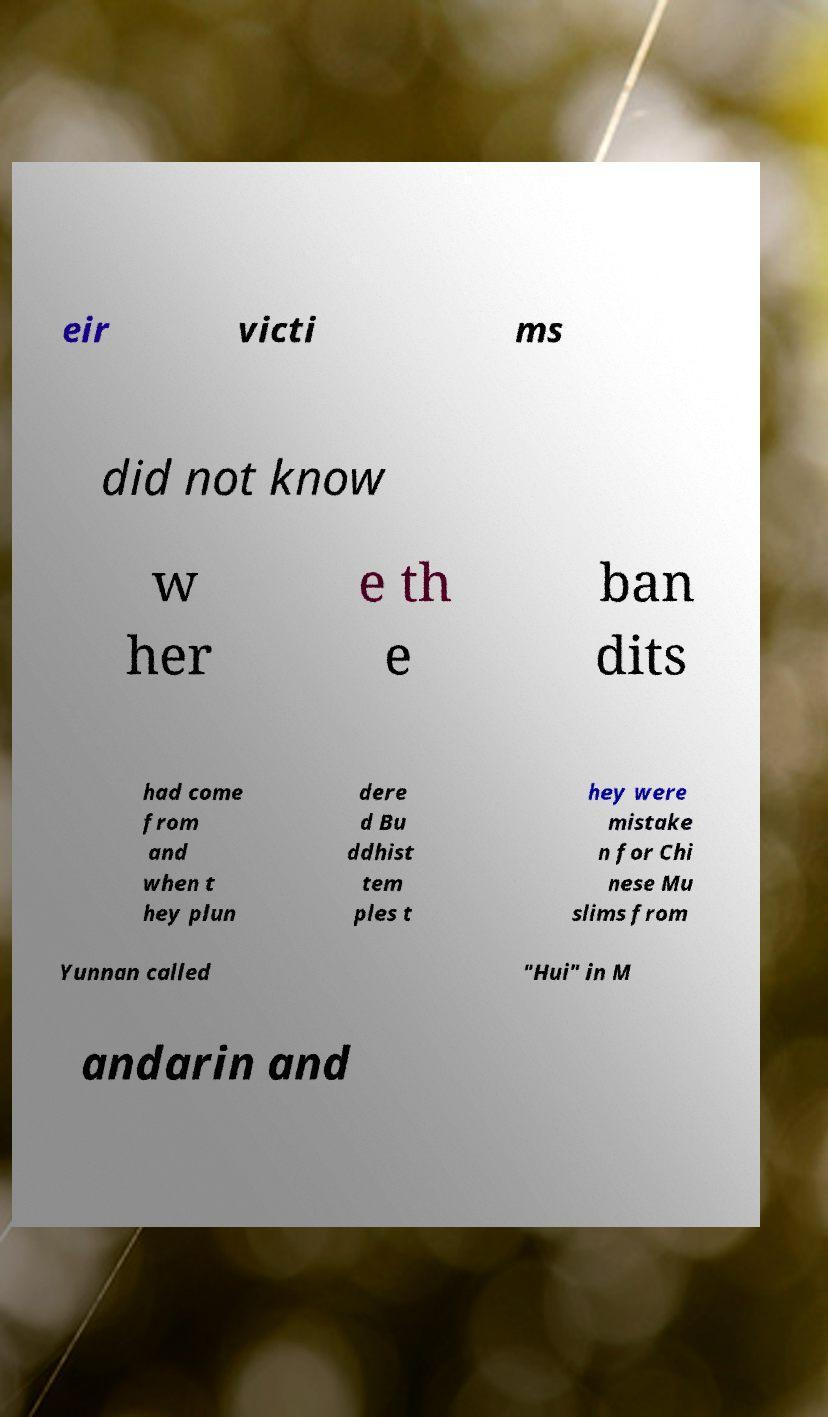What messages or text are displayed in this image? I need them in a readable, typed format. eir victi ms did not know w her e th e ban dits had come from and when t hey plun dere d Bu ddhist tem ples t hey were mistake n for Chi nese Mu slims from Yunnan called "Hui" in M andarin and 